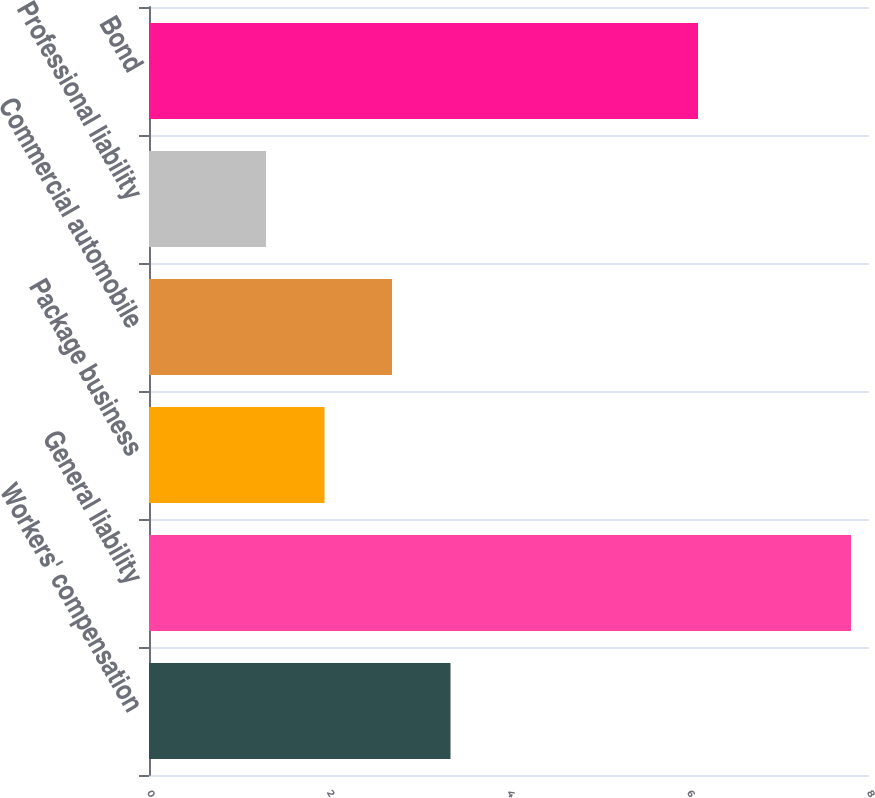<chart> <loc_0><loc_0><loc_500><loc_500><bar_chart><fcel>Workers' compensation<fcel>General liability<fcel>Package business<fcel>Commercial automobile<fcel>Professional liability<fcel>Bond<nl><fcel>3.35<fcel>7.8<fcel>1.95<fcel>2.7<fcel>1.3<fcel>6.1<nl></chart> 